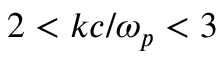<formula> <loc_0><loc_0><loc_500><loc_500>2 < k c / \omega _ { p } < 3</formula> 